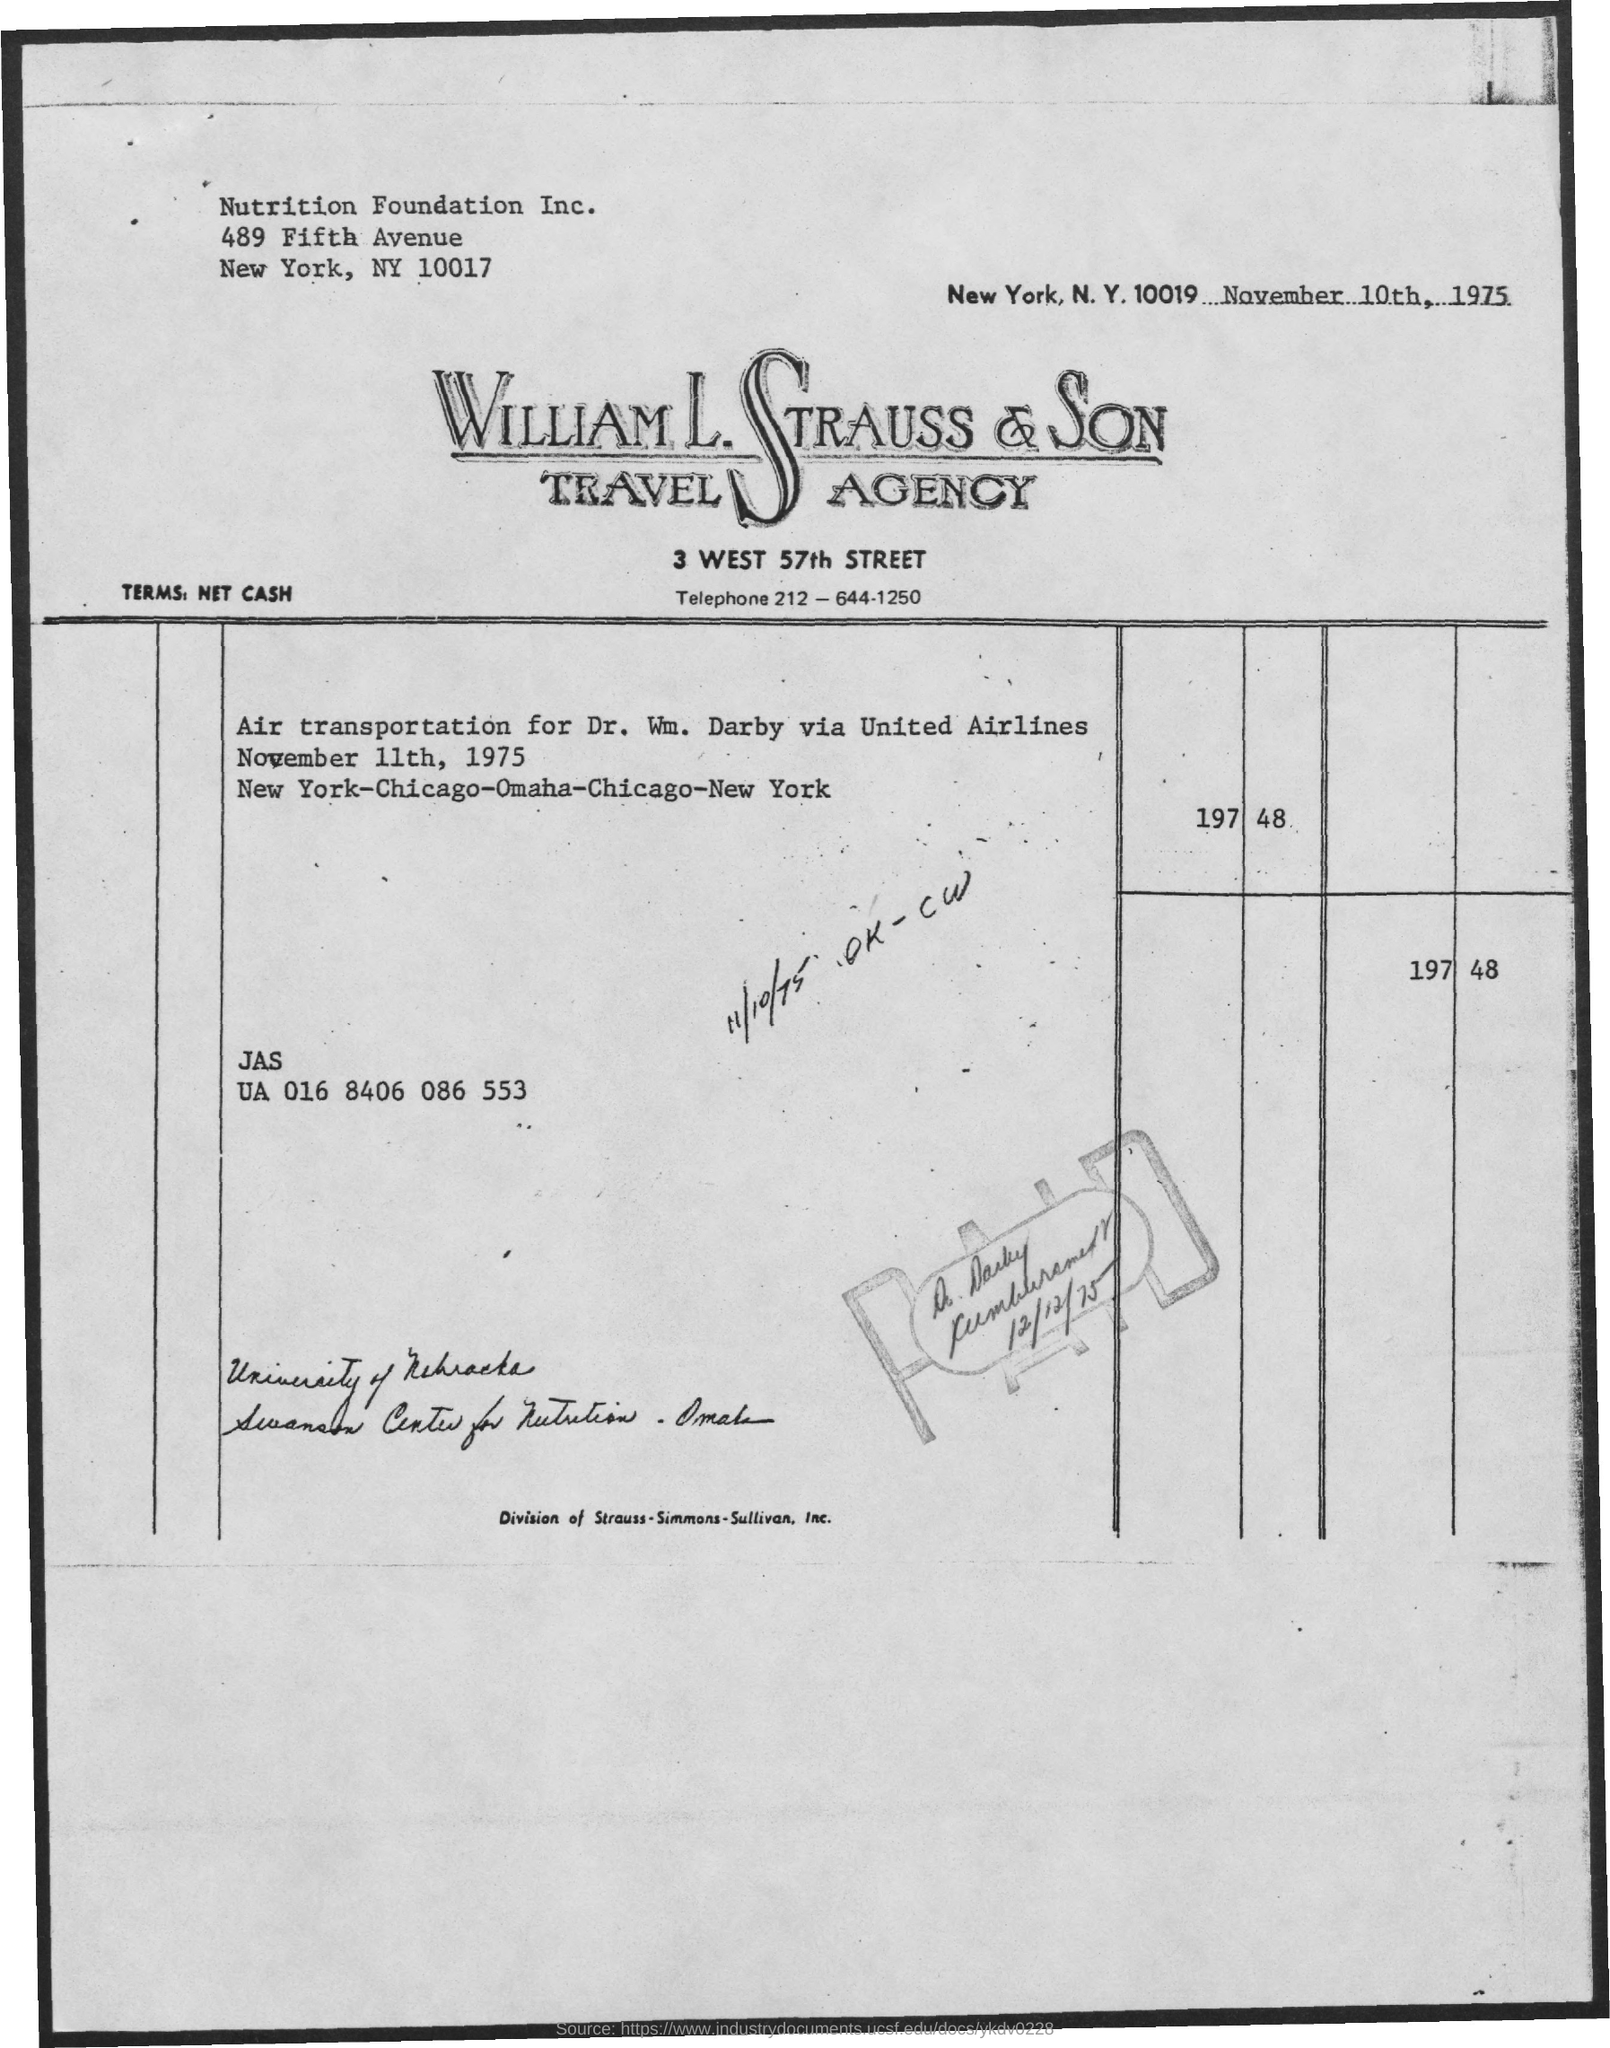Point out several critical features in this image. The invoice is addressed to Nutrition Foundation Inc. The issued date of this invoice is November 10th, 1975. 